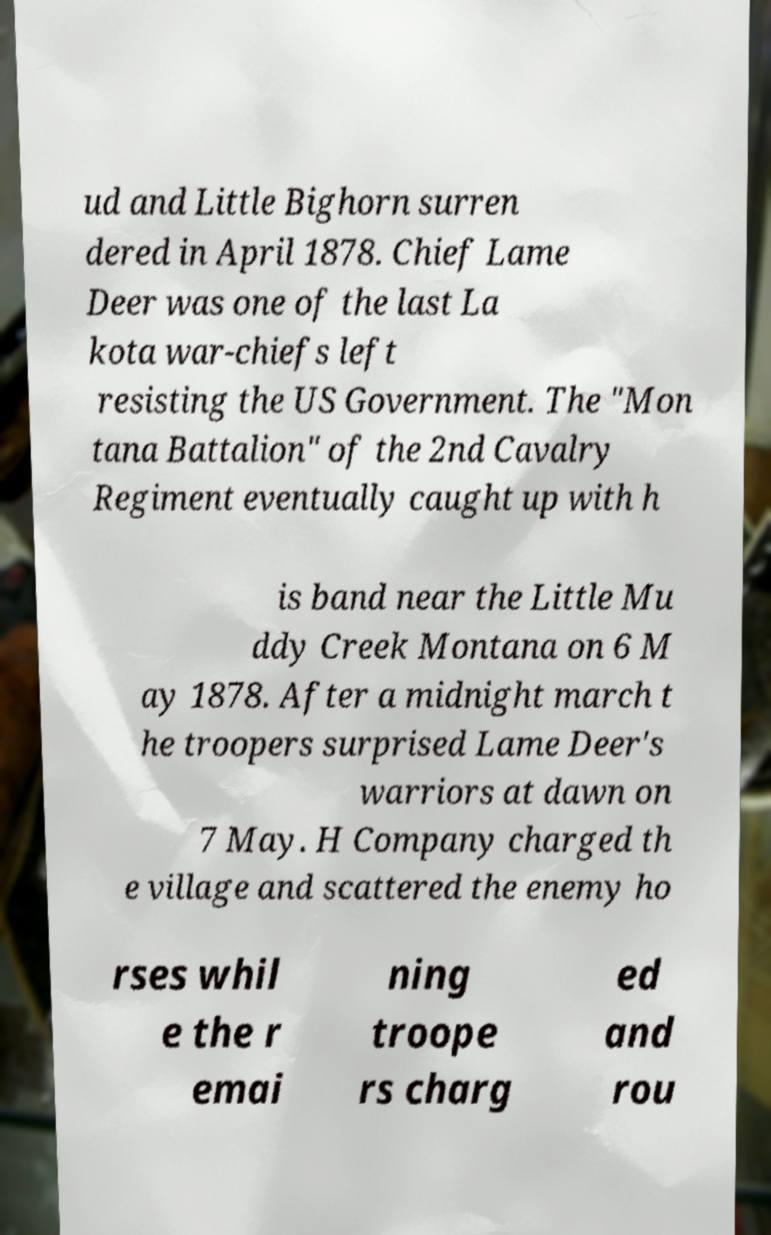Could you assist in decoding the text presented in this image and type it out clearly? ud and Little Bighorn surren dered in April 1878. Chief Lame Deer was one of the last La kota war-chiefs left resisting the US Government. The "Mon tana Battalion" of the 2nd Cavalry Regiment eventually caught up with h is band near the Little Mu ddy Creek Montana on 6 M ay 1878. After a midnight march t he troopers surprised Lame Deer's warriors at dawn on 7 May. H Company charged th e village and scattered the enemy ho rses whil e the r emai ning troope rs charg ed and rou 